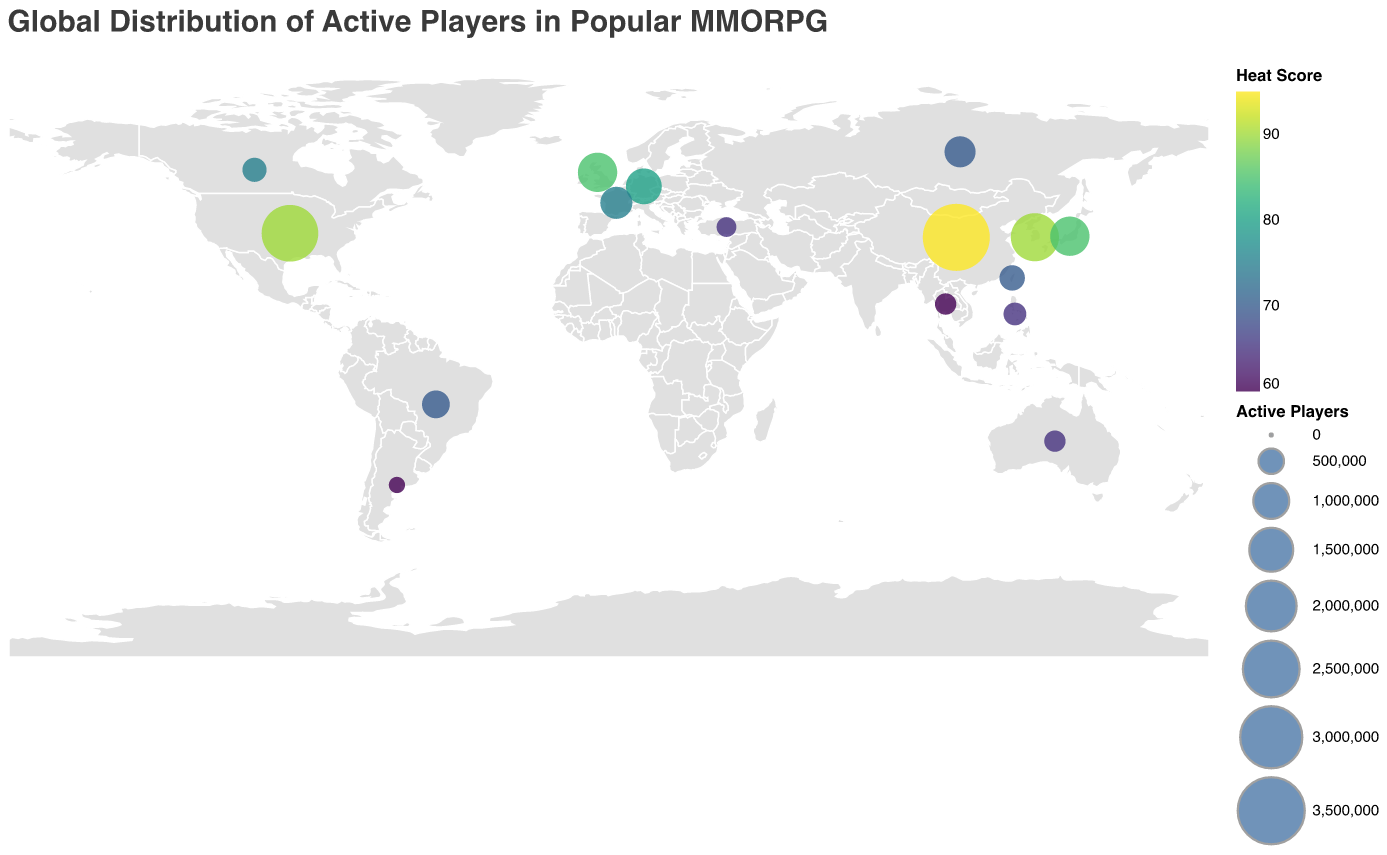How many regions are represented in the figure? The figure shows data for North America, Europe, Asia, Oceania, South America, Middle East, and Southeast Asia. Each of these counts as one region.
Answer: 7 Which country has the highest number of active players? By examining the size of the circles, the largest one corresponds to China in Asia with 3,500,000 active players.
Answer: China What is the average Heat Score for the European countries in the figure? The Heat Scores in Europe are 85 (United Kingdom), 80 (Germany), 75 (France), and 70 (Russia). The sum of these scores is 310, and there are 4 countries, so the average is 310 / 4 = 77.5
Answer: 77.5 How does the active player count in the United States compare to that in South Korea? The United States has 2,500,000 active players, whereas South Korea has 1,800,000. Subtracting these, 2,500,000 - 1,800,000 = 700,000, so the U.S. has 700,000 more active players.
Answer: 700,000 more Which region has the lowest Heat Score on average? First, calculate the average Heat Score for each region. North America (90, 75) averages 82.5, Europe (85, 80, 75, 70) averages 77.5, Asia (95, 90, 85, 70) averages 85, Oceania (65) averages 65, South America (70, 60) averages 65, Middle East (65) averages 65, and Southeast Asia (65, 60) averages 62.5. The lowest average Heat Score is in Southeast Asia.
Answer: Southeast Asia Comparing the regions, which one has the highest concentration of active players? The Heat Score represents concentration. Asia has the highest concentration with a Heat Score of 95 for China and 90 for South Korea.
Answer: Asia What's the total number of active players in South America according to the figure? South America includes Brazil with 600,000 active players and Argentina with 200,000. Adding these gives 600,000 + 200,000 = 800,000.
Answer: 800,000 Which country in Europe has the least number of active players? The countries in Europe and their player counts are: United Kingdom (1,200,000), Germany (1,000,000), France (800,000), and Russia (750,000). Russia has the least with 750,000 players.
Answer: Russia How does the Heat Score for Japan compare to that for the Philippines? Japan's Heat Score is 85, while the Philippines' is 65. Subtracting these, 85 - 65 = 20, so Japan has a higher Heat Score by 20.
Answer: 20 higher What is the range of the Heat Scores across all regions? The highest Heat Score is 95 (China), and the lowest Heat Score is 60 (Argentina and Thailand). The range is 95 - 60 = 35.
Answer: 35 